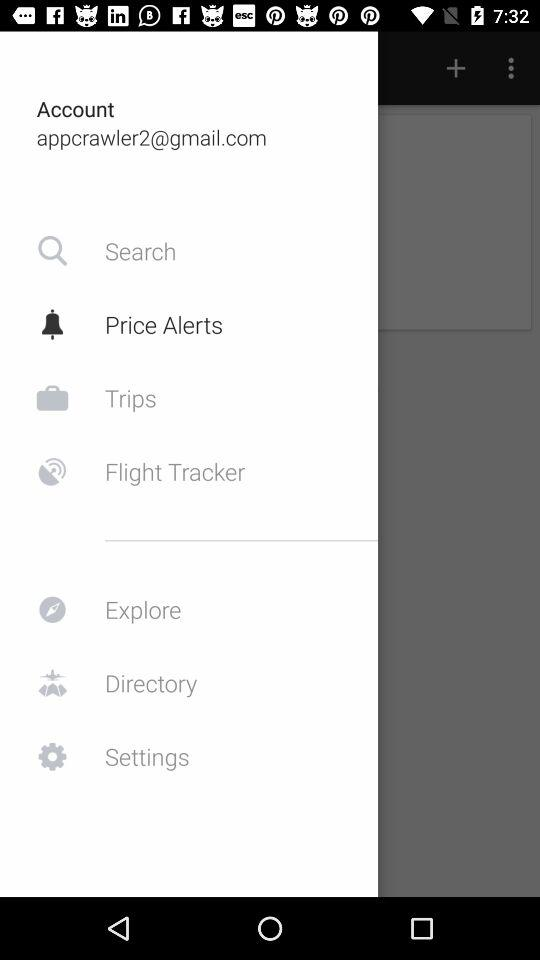Which item is selected? The selected item is "Price Alerts". 